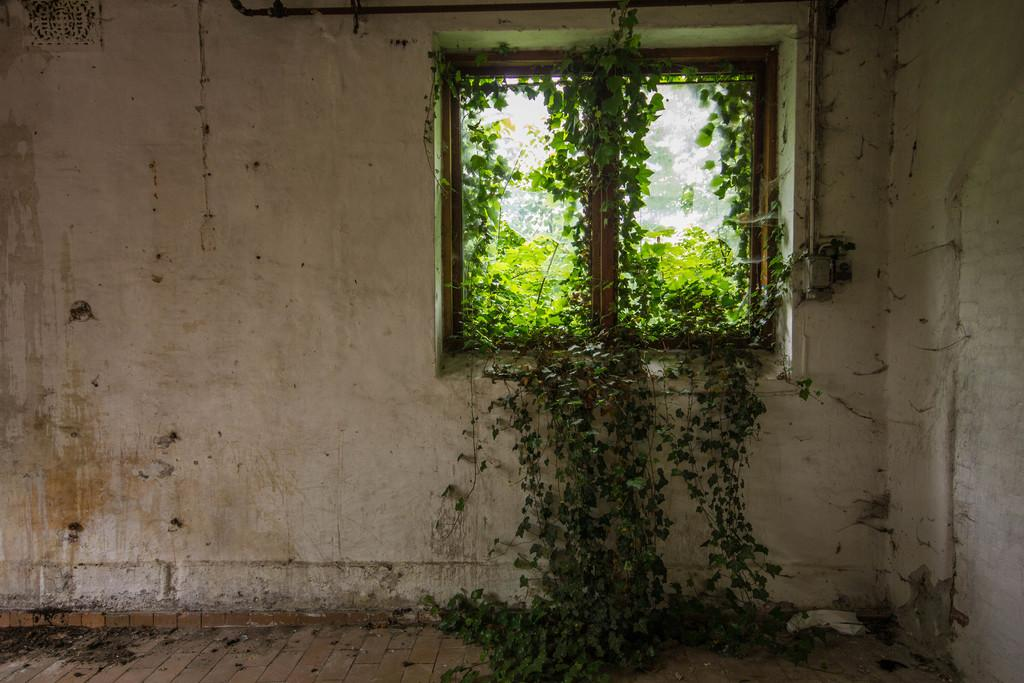What type of setting is depicted in the image? The image shows an inside view of a room. What can be seen in the background of the room? There is a window visible in the background of the room. What is located near the window? A group of plants is present near the window. What type of powder is being used by the woman in the image? There is no woman present in the image, and therefore no powder usage can be observed. 